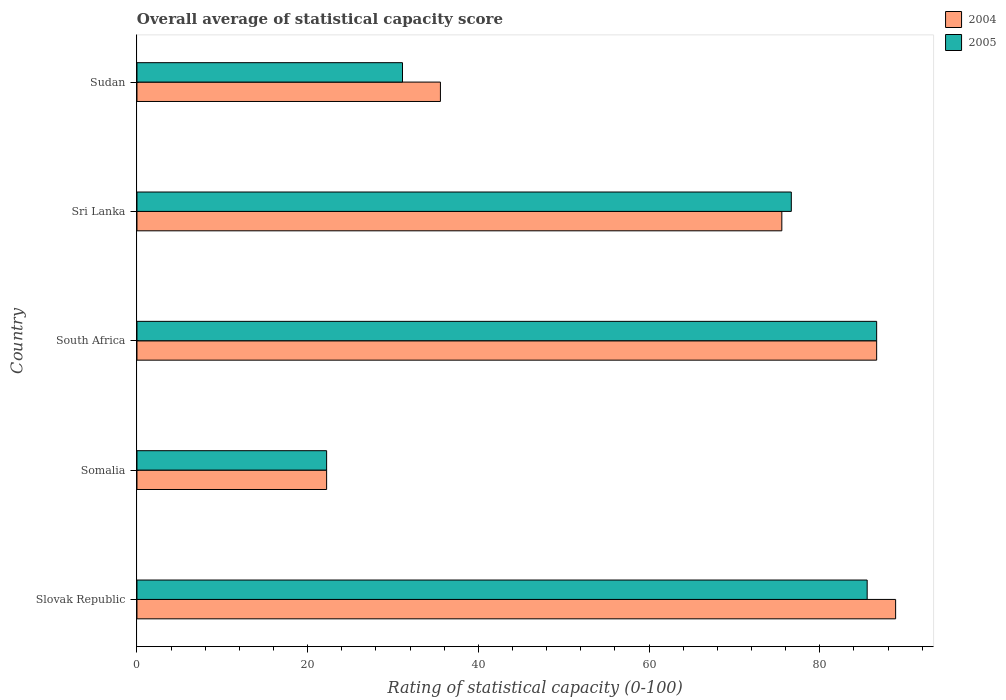How many groups of bars are there?
Give a very brief answer. 5. How many bars are there on the 5th tick from the top?
Offer a terse response. 2. How many bars are there on the 5th tick from the bottom?
Offer a very short reply. 2. What is the label of the 5th group of bars from the top?
Provide a succinct answer. Slovak Republic. What is the rating of statistical capacity in 2004 in Slovak Republic?
Provide a succinct answer. 88.89. Across all countries, what is the maximum rating of statistical capacity in 2004?
Keep it short and to the point. 88.89. Across all countries, what is the minimum rating of statistical capacity in 2004?
Your answer should be very brief. 22.22. In which country was the rating of statistical capacity in 2004 maximum?
Provide a succinct answer. Slovak Republic. In which country was the rating of statistical capacity in 2005 minimum?
Keep it short and to the point. Somalia. What is the total rating of statistical capacity in 2005 in the graph?
Your answer should be compact. 302.22. What is the difference between the rating of statistical capacity in 2005 in South Africa and that in Sudan?
Your answer should be very brief. 55.56. What is the difference between the rating of statistical capacity in 2005 in Sri Lanka and the rating of statistical capacity in 2004 in Sudan?
Ensure brevity in your answer.  41.11. What is the average rating of statistical capacity in 2004 per country?
Ensure brevity in your answer.  61.78. In how many countries, is the rating of statistical capacity in 2004 greater than 28 ?
Provide a succinct answer. 4. What is the ratio of the rating of statistical capacity in 2004 in Sri Lanka to that in Sudan?
Your response must be concise. 2.12. What is the difference between the highest and the second highest rating of statistical capacity in 2004?
Give a very brief answer. 2.22. What is the difference between the highest and the lowest rating of statistical capacity in 2005?
Your answer should be compact. 64.44. In how many countries, is the rating of statistical capacity in 2004 greater than the average rating of statistical capacity in 2004 taken over all countries?
Ensure brevity in your answer.  3. What does the 2nd bar from the bottom in Sri Lanka represents?
Your answer should be very brief. 2005. How many countries are there in the graph?
Offer a terse response. 5. What is the difference between two consecutive major ticks on the X-axis?
Your answer should be compact. 20. Are the values on the major ticks of X-axis written in scientific E-notation?
Your answer should be very brief. No. Where does the legend appear in the graph?
Offer a very short reply. Top right. How many legend labels are there?
Offer a very short reply. 2. What is the title of the graph?
Make the answer very short. Overall average of statistical capacity score. What is the label or title of the X-axis?
Give a very brief answer. Rating of statistical capacity (0-100). What is the label or title of the Y-axis?
Make the answer very short. Country. What is the Rating of statistical capacity (0-100) of 2004 in Slovak Republic?
Provide a succinct answer. 88.89. What is the Rating of statistical capacity (0-100) of 2005 in Slovak Republic?
Give a very brief answer. 85.56. What is the Rating of statistical capacity (0-100) of 2004 in Somalia?
Make the answer very short. 22.22. What is the Rating of statistical capacity (0-100) of 2005 in Somalia?
Provide a succinct answer. 22.22. What is the Rating of statistical capacity (0-100) of 2004 in South Africa?
Offer a terse response. 86.67. What is the Rating of statistical capacity (0-100) of 2005 in South Africa?
Your answer should be compact. 86.67. What is the Rating of statistical capacity (0-100) of 2004 in Sri Lanka?
Make the answer very short. 75.56. What is the Rating of statistical capacity (0-100) in 2005 in Sri Lanka?
Provide a short and direct response. 76.67. What is the Rating of statistical capacity (0-100) of 2004 in Sudan?
Your answer should be very brief. 35.56. What is the Rating of statistical capacity (0-100) in 2005 in Sudan?
Provide a short and direct response. 31.11. Across all countries, what is the maximum Rating of statistical capacity (0-100) of 2004?
Ensure brevity in your answer.  88.89. Across all countries, what is the maximum Rating of statistical capacity (0-100) in 2005?
Your answer should be very brief. 86.67. Across all countries, what is the minimum Rating of statistical capacity (0-100) of 2004?
Offer a terse response. 22.22. Across all countries, what is the minimum Rating of statistical capacity (0-100) in 2005?
Make the answer very short. 22.22. What is the total Rating of statistical capacity (0-100) in 2004 in the graph?
Make the answer very short. 308.89. What is the total Rating of statistical capacity (0-100) in 2005 in the graph?
Provide a succinct answer. 302.22. What is the difference between the Rating of statistical capacity (0-100) in 2004 in Slovak Republic and that in Somalia?
Your response must be concise. 66.67. What is the difference between the Rating of statistical capacity (0-100) of 2005 in Slovak Republic and that in Somalia?
Ensure brevity in your answer.  63.33. What is the difference between the Rating of statistical capacity (0-100) of 2004 in Slovak Republic and that in South Africa?
Provide a short and direct response. 2.22. What is the difference between the Rating of statistical capacity (0-100) in 2005 in Slovak Republic and that in South Africa?
Offer a terse response. -1.11. What is the difference between the Rating of statistical capacity (0-100) of 2004 in Slovak Republic and that in Sri Lanka?
Provide a succinct answer. 13.33. What is the difference between the Rating of statistical capacity (0-100) of 2005 in Slovak Republic and that in Sri Lanka?
Ensure brevity in your answer.  8.89. What is the difference between the Rating of statistical capacity (0-100) of 2004 in Slovak Republic and that in Sudan?
Ensure brevity in your answer.  53.33. What is the difference between the Rating of statistical capacity (0-100) of 2005 in Slovak Republic and that in Sudan?
Keep it short and to the point. 54.44. What is the difference between the Rating of statistical capacity (0-100) in 2004 in Somalia and that in South Africa?
Your answer should be very brief. -64.44. What is the difference between the Rating of statistical capacity (0-100) of 2005 in Somalia and that in South Africa?
Make the answer very short. -64.44. What is the difference between the Rating of statistical capacity (0-100) in 2004 in Somalia and that in Sri Lanka?
Give a very brief answer. -53.33. What is the difference between the Rating of statistical capacity (0-100) in 2005 in Somalia and that in Sri Lanka?
Give a very brief answer. -54.44. What is the difference between the Rating of statistical capacity (0-100) in 2004 in Somalia and that in Sudan?
Give a very brief answer. -13.33. What is the difference between the Rating of statistical capacity (0-100) of 2005 in Somalia and that in Sudan?
Your answer should be very brief. -8.89. What is the difference between the Rating of statistical capacity (0-100) of 2004 in South Africa and that in Sri Lanka?
Ensure brevity in your answer.  11.11. What is the difference between the Rating of statistical capacity (0-100) in 2004 in South Africa and that in Sudan?
Give a very brief answer. 51.11. What is the difference between the Rating of statistical capacity (0-100) in 2005 in South Africa and that in Sudan?
Your response must be concise. 55.56. What is the difference between the Rating of statistical capacity (0-100) of 2004 in Sri Lanka and that in Sudan?
Offer a very short reply. 40. What is the difference between the Rating of statistical capacity (0-100) in 2005 in Sri Lanka and that in Sudan?
Give a very brief answer. 45.56. What is the difference between the Rating of statistical capacity (0-100) of 2004 in Slovak Republic and the Rating of statistical capacity (0-100) of 2005 in Somalia?
Make the answer very short. 66.67. What is the difference between the Rating of statistical capacity (0-100) of 2004 in Slovak Republic and the Rating of statistical capacity (0-100) of 2005 in South Africa?
Offer a terse response. 2.22. What is the difference between the Rating of statistical capacity (0-100) in 2004 in Slovak Republic and the Rating of statistical capacity (0-100) in 2005 in Sri Lanka?
Give a very brief answer. 12.22. What is the difference between the Rating of statistical capacity (0-100) of 2004 in Slovak Republic and the Rating of statistical capacity (0-100) of 2005 in Sudan?
Offer a very short reply. 57.78. What is the difference between the Rating of statistical capacity (0-100) of 2004 in Somalia and the Rating of statistical capacity (0-100) of 2005 in South Africa?
Your response must be concise. -64.44. What is the difference between the Rating of statistical capacity (0-100) of 2004 in Somalia and the Rating of statistical capacity (0-100) of 2005 in Sri Lanka?
Your answer should be very brief. -54.44. What is the difference between the Rating of statistical capacity (0-100) of 2004 in Somalia and the Rating of statistical capacity (0-100) of 2005 in Sudan?
Your answer should be very brief. -8.89. What is the difference between the Rating of statistical capacity (0-100) in 2004 in South Africa and the Rating of statistical capacity (0-100) in 2005 in Sudan?
Ensure brevity in your answer.  55.56. What is the difference between the Rating of statistical capacity (0-100) in 2004 in Sri Lanka and the Rating of statistical capacity (0-100) in 2005 in Sudan?
Provide a succinct answer. 44.44. What is the average Rating of statistical capacity (0-100) of 2004 per country?
Your answer should be very brief. 61.78. What is the average Rating of statistical capacity (0-100) of 2005 per country?
Offer a terse response. 60.44. What is the difference between the Rating of statistical capacity (0-100) of 2004 and Rating of statistical capacity (0-100) of 2005 in Slovak Republic?
Your answer should be very brief. 3.33. What is the difference between the Rating of statistical capacity (0-100) of 2004 and Rating of statistical capacity (0-100) of 2005 in South Africa?
Your response must be concise. 0. What is the difference between the Rating of statistical capacity (0-100) in 2004 and Rating of statistical capacity (0-100) in 2005 in Sri Lanka?
Make the answer very short. -1.11. What is the difference between the Rating of statistical capacity (0-100) in 2004 and Rating of statistical capacity (0-100) in 2005 in Sudan?
Your answer should be very brief. 4.44. What is the ratio of the Rating of statistical capacity (0-100) of 2005 in Slovak Republic to that in Somalia?
Provide a short and direct response. 3.85. What is the ratio of the Rating of statistical capacity (0-100) of 2004 in Slovak Republic to that in South Africa?
Offer a terse response. 1.03. What is the ratio of the Rating of statistical capacity (0-100) of 2005 in Slovak Republic to that in South Africa?
Offer a very short reply. 0.99. What is the ratio of the Rating of statistical capacity (0-100) in 2004 in Slovak Republic to that in Sri Lanka?
Provide a short and direct response. 1.18. What is the ratio of the Rating of statistical capacity (0-100) of 2005 in Slovak Republic to that in Sri Lanka?
Your answer should be very brief. 1.12. What is the ratio of the Rating of statistical capacity (0-100) of 2004 in Slovak Republic to that in Sudan?
Keep it short and to the point. 2.5. What is the ratio of the Rating of statistical capacity (0-100) of 2005 in Slovak Republic to that in Sudan?
Your response must be concise. 2.75. What is the ratio of the Rating of statistical capacity (0-100) of 2004 in Somalia to that in South Africa?
Offer a very short reply. 0.26. What is the ratio of the Rating of statistical capacity (0-100) in 2005 in Somalia to that in South Africa?
Ensure brevity in your answer.  0.26. What is the ratio of the Rating of statistical capacity (0-100) of 2004 in Somalia to that in Sri Lanka?
Offer a very short reply. 0.29. What is the ratio of the Rating of statistical capacity (0-100) in 2005 in Somalia to that in Sri Lanka?
Ensure brevity in your answer.  0.29. What is the ratio of the Rating of statistical capacity (0-100) of 2004 in South Africa to that in Sri Lanka?
Provide a succinct answer. 1.15. What is the ratio of the Rating of statistical capacity (0-100) in 2005 in South Africa to that in Sri Lanka?
Your answer should be compact. 1.13. What is the ratio of the Rating of statistical capacity (0-100) of 2004 in South Africa to that in Sudan?
Give a very brief answer. 2.44. What is the ratio of the Rating of statistical capacity (0-100) of 2005 in South Africa to that in Sudan?
Ensure brevity in your answer.  2.79. What is the ratio of the Rating of statistical capacity (0-100) of 2004 in Sri Lanka to that in Sudan?
Your answer should be compact. 2.12. What is the ratio of the Rating of statistical capacity (0-100) in 2005 in Sri Lanka to that in Sudan?
Offer a terse response. 2.46. What is the difference between the highest and the second highest Rating of statistical capacity (0-100) of 2004?
Make the answer very short. 2.22. What is the difference between the highest and the second highest Rating of statistical capacity (0-100) in 2005?
Provide a short and direct response. 1.11. What is the difference between the highest and the lowest Rating of statistical capacity (0-100) in 2004?
Keep it short and to the point. 66.67. What is the difference between the highest and the lowest Rating of statistical capacity (0-100) in 2005?
Provide a succinct answer. 64.44. 